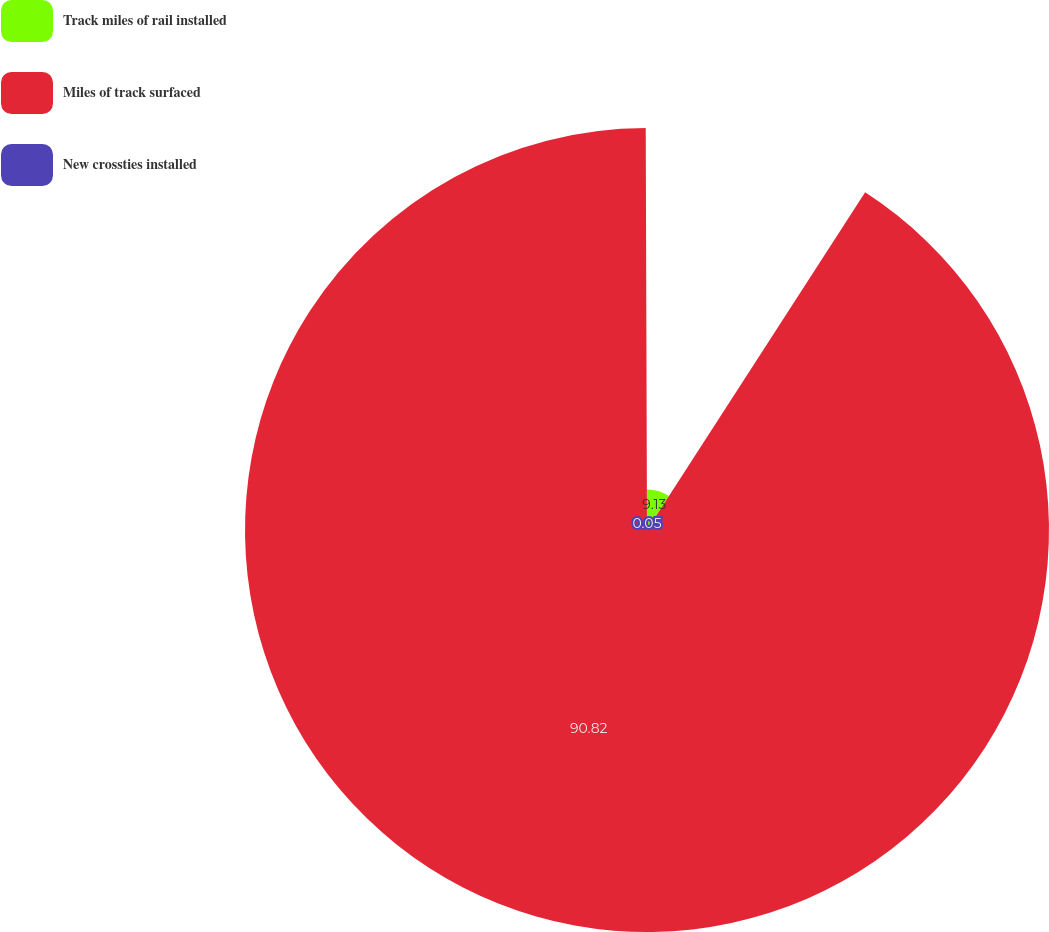Convert chart. <chart><loc_0><loc_0><loc_500><loc_500><pie_chart><fcel>Track miles of rail installed<fcel>Miles of track surfaced<fcel>New crossties installed<nl><fcel>9.13%<fcel>90.83%<fcel>0.05%<nl></chart> 